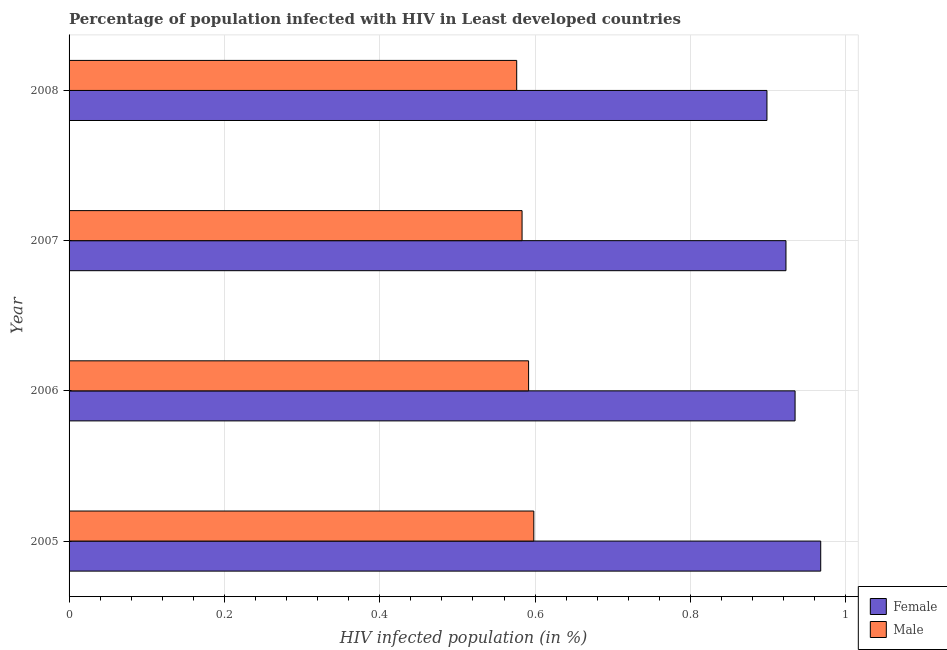How many groups of bars are there?
Your response must be concise. 4. Are the number of bars on each tick of the Y-axis equal?
Ensure brevity in your answer.  Yes. How many bars are there on the 4th tick from the top?
Offer a very short reply. 2. What is the label of the 1st group of bars from the top?
Keep it short and to the point. 2008. What is the percentage of females who are infected with hiv in 2007?
Your response must be concise. 0.92. Across all years, what is the maximum percentage of males who are infected with hiv?
Provide a short and direct response. 0.6. Across all years, what is the minimum percentage of females who are infected with hiv?
Offer a terse response. 0.9. In which year was the percentage of males who are infected with hiv maximum?
Your answer should be very brief. 2005. In which year was the percentage of females who are infected with hiv minimum?
Provide a short and direct response. 2008. What is the total percentage of females who are infected with hiv in the graph?
Give a very brief answer. 3.72. What is the difference between the percentage of males who are infected with hiv in 2007 and that in 2008?
Provide a short and direct response. 0.01. What is the difference between the percentage of females who are infected with hiv in 2008 and the percentage of males who are infected with hiv in 2006?
Make the answer very short. 0.31. What is the average percentage of males who are infected with hiv per year?
Keep it short and to the point. 0.59. In the year 2007, what is the difference between the percentage of females who are infected with hiv and percentage of males who are infected with hiv?
Keep it short and to the point. 0.34. What is the ratio of the percentage of females who are infected with hiv in 2005 to that in 2007?
Ensure brevity in your answer.  1.05. Is the percentage of males who are infected with hiv in 2006 less than that in 2007?
Make the answer very short. No. Is the difference between the percentage of males who are infected with hiv in 2006 and 2007 greater than the difference between the percentage of females who are infected with hiv in 2006 and 2007?
Make the answer very short. No. What is the difference between the highest and the second highest percentage of males who are infected with hiv?
Provide a succinct answer. 0.01. What is the difference between the highest and the lowest percentage of females who are infected with hiv?
Ensure brevity in your answer.  0.07. In how many years, is the percentage of females who are infected with hiv greater than the average percentage of females who are infected with hiv taken over all years?
Your answer should be very brief. 2. What does the 2nd bar from the top in 2005 represents?
Offer a terse response. Female. How many bars are there?
Offer a very short reply. 8. How many years are there in the graph?
Offer a very short reply. 4. What is the difference between two consecutive major ticks on the X-axis?
Your answer should be compact. 0.2. What is the title of the graph?
Your answer should be very brief. Percentage of population infected with HIV in Least developed countries. Does "Health Care" appear as one of the legend labels in the graph?
Make the answer very short. No. What is the label or title of the X-axis?
Ensure brevity in your answer.  HIV infected population (in %). What is the label or title of the Y-axis?
Ensure brevity in your answer.  Year. What is the HIV infected population (in %) of Female in 2005?
Ensure brevity in your answer.  0.97. What is the HIV infected population (in %) of Male in 2005?
Give a very brief answer. 0.6. What is the HIV infected population (in %) of Female in 2006?
Your response must be concise. 0.93. What is the HIV infected population (in %) of Male in 2006?
Offer a terse response. 0.59. What is the HIV infected population (in %) of Female in 2007?
Your answer should be very brief. 0.92. What is the HIV infected population (in %) of Male in 2007?
Offer a terse response. 0.58. What is the HIV infected population (in %) in Female in 2008?
Provide a short and direct response. 0.9. What is the HIV infected population (in %) in Male in 2008?
Make the answer very short. 0.58. Across all years, what is the maximum HIV infected population (in %) of Female?
Your response must be concise. 0.97. Across all years, what is the maximum HIV infected population (in %) in Male?
Offer a very short reply. 0.6. Across all years, what is the minimum HIV infected population (in %) of Female?
Keep it short and to the point. 0.9. Across all years, what is the minimum HIV infected population (in %) of Male?
Provide a short and direct response. 0.58. What is the total HIV infected population (in %) of Female in the graph?
Ensure brevity in your answer.  3.72. What is the total HIV infected population (in %) in Male in the graph?
Give a very brief answer. 2.35. What is the difference between the HIV infected population (in %) in Female in 2005 and that in 2006?
Keep it short and to the point. 0.03. What is the difference between the HIV infected population (in %) of Male in 2005 and that in 2006?
Ensure brevity in your answer.  0.01. What is the difference between the HIV infected population (in %) in Female in 2005 and that in 2007?
Offer a very short reply. 0.04. What is the difference between the HIV infected population (in %) in Male in 2005 and that in 2007?
Your response must be concise. 0.02. What is the difference between the HIV infected population (in %) in Female in 2005 and that in 2008?
Give a very brief answer. 0.07. What is the difference between the HIV infected population (in %) in Male in 2005 and that in 2008?
Your answer should be compact. 0.02. What is the difference between the HIV infected population (in %) in Female in 2006 and that in 2007?
Your answer should be compact. 0.01. What is the difference between the HIV infected population (in %) of Male in 2006 and that in 2007?
Keep it short and to the point. 0.01. What is the difference between the HIV infected population (in %) of Female in 2006 and that in 2008?
Make the answer very short. 0.04. What is the difference between the HIV infected population (in %) of Male in 2006 and that in 2008?
Your answer should be compact. 0.02. What is the difference between the HIV infected population (in %) of Female in 2007 and that in 2008?
Provide a short and direct response. 0.02. What is the difference between the HIV infected population (in %) of Male in 2007 and that in 2008?
Your response must be concise. 0.01. What is the difference between the HIV infected population (in %) in Female in 2005 and the HIV infected population (in %) in Male in 2006?
Give a very brief answer. 0.38. What is the difference between the HIV infected population (in %) of Female in 2005 and the HIV infected population (in %) of Male in 2007?
Your answer should be very brief. 0.38. What is the difference between the HIV infected population (in %) in Female in 2005 and the HIV infected population (in %) in Male in 2008?
Offer a terse response. 0.39. What is the difference between the HIV infected population (in %) of Female in 2006 and the HIV infected population (in %) of Male in 2007?
Offer a very short reply. 0.35. What is the difference between the HIV infected population (in %) in Female in 2006 and the HIV infected population (in %) in Male in 2008?
Provide a succinct answer. 0.36. What is the difference between the HIV infected population (in %) of Female in 2007 and the HIV infected population (in %) of Male in 2008?
Offer a terse response. 0.35. What is the average HIV infected population (in %) in Male per year?
Offer a terse response. 0.59. In the year 2005, what is the difference between the HIV infected population (in %) of Female and HIV infected population (in %) of Male?
Give a very brief answer. 0.37. In the year 2006, what is the difference between the HIV infected population (in %) in Female and HIV infected population (in %) in Male?
Ensure brevity in your answer.  0.34. In the year 2007, what is the difference between the HIV infected population (in %) of Female and HIV infected population (in %) of Male?
Ensure brevity in your answer.  0.34. In the year 2008, what is the difference between the HIV infected population (in %) of Female and HIV infected population (in %) of Male?
Offer a terse response. 0.32. What is the ratio of the HIV infected population (in %) in Female in 2005 to that in 2006?
Your answer should be very brief. 1.04. What is the ratio of the HIV infected population (in %) of Male in 2005 to that in 2006?
Offer a terse response. 1.01. What is the ratio of the HIV infected population (in %) of Female in 2005 to that in 2007?
Your answer should be very brief. 1.05. What is the ratio of the HIV infected population (in %) of Male in 2005 to that in 2007?
Ensure brevity in your answer.  1.03. What is the ratio of the HIV infected population (in %) in Female in 2005 to that in 2008?
Your answer should be compact. 1.08. What is the ratio of the HIV infected population (in %) of Male in 2005 to that in 2008?
Ensure brevity in your answer.  1.04. What is the ratio of the HIV infected population (in %) in Female in 2006 to that in 2007?
Give a very brief answer. 1.01. What is the ratio of the HIV infected population (in %) of Male in 2006 to that in 2007?
Provide a succinct answer. 1.01. What is the ratio of the HIV infected population (in %) of Female in 2006 to that in 2008?
Offer a very short reply. 1.04. What is the ratio of the HIV infected population (in %) in Male in 2006 to that in 2008?
Offer a very short reply. 1.03. What is the ratio of the HIV infected population (in %) of Female in 2007 to that in 2008?
Provide a short and direct response. 1.03. What is the difference between the highest and the second highest HIV infected population (in %) of Female?
Provide a short and direct response. 0.03. What is the difference between the highest and the second highest HIV infected population (in %) in Male?
Your response must be concise. 0.01. What is the difference between the highest and the lowest HIV infected population (in %) in Female?
Your answer should be compact. 0.07. What is the difference between the highest and the lowest HIV infected population (in %) in Male?
Make the answer very short. 0.02. 